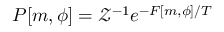<formula> <loc_0><loc_0><loc_500><loc_500>P [ m , \phi ] = \mathcal { Z } ^ { - 1 } e ^ { - F [ m , \phi ] / T }</formula> 